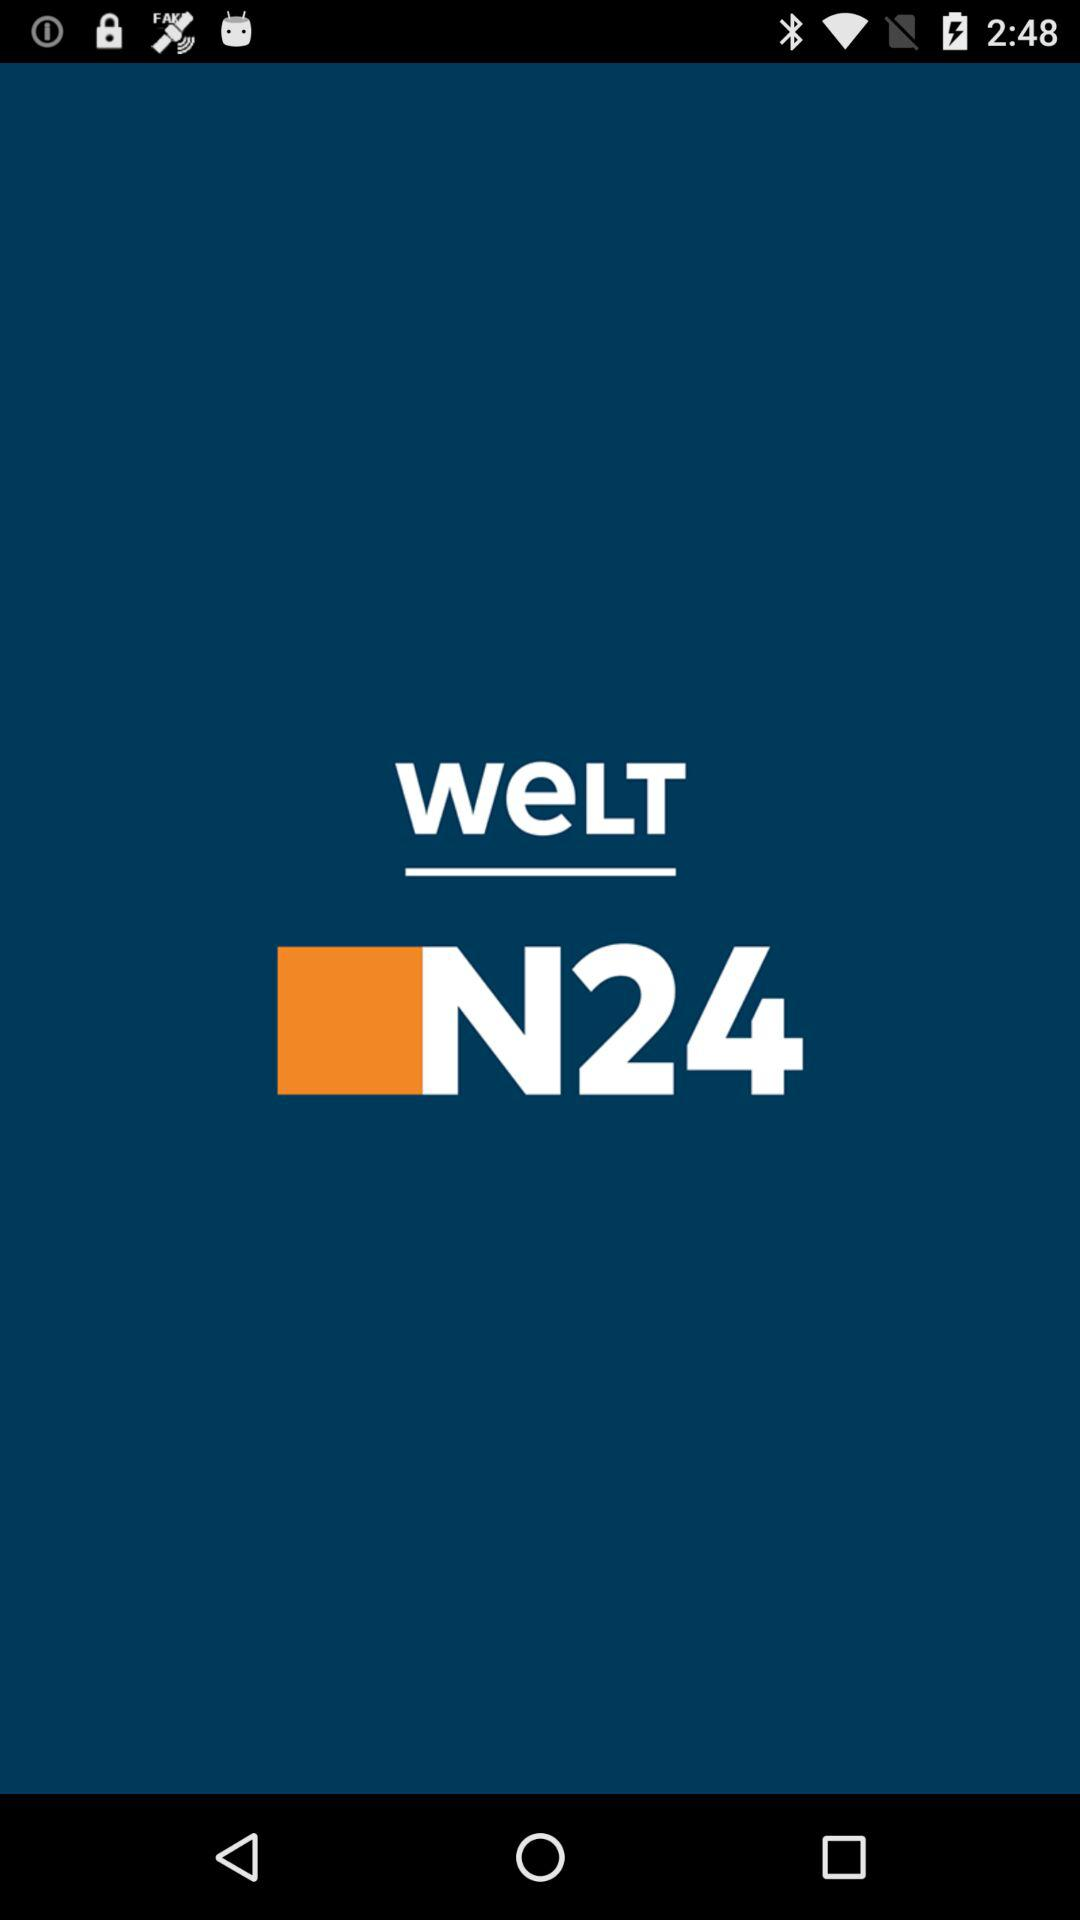Which text is closer to the middle of the screen, WELT or N24?
Answer the question using a single word or phrase. WELT 